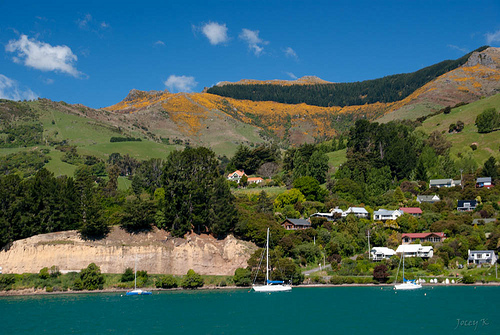<image>
Can you confirm if the house is behind the mountain? Yes. From this viewpoint, the house is positioned behind the mountain, with the mountain partially or fully occluding the house. 